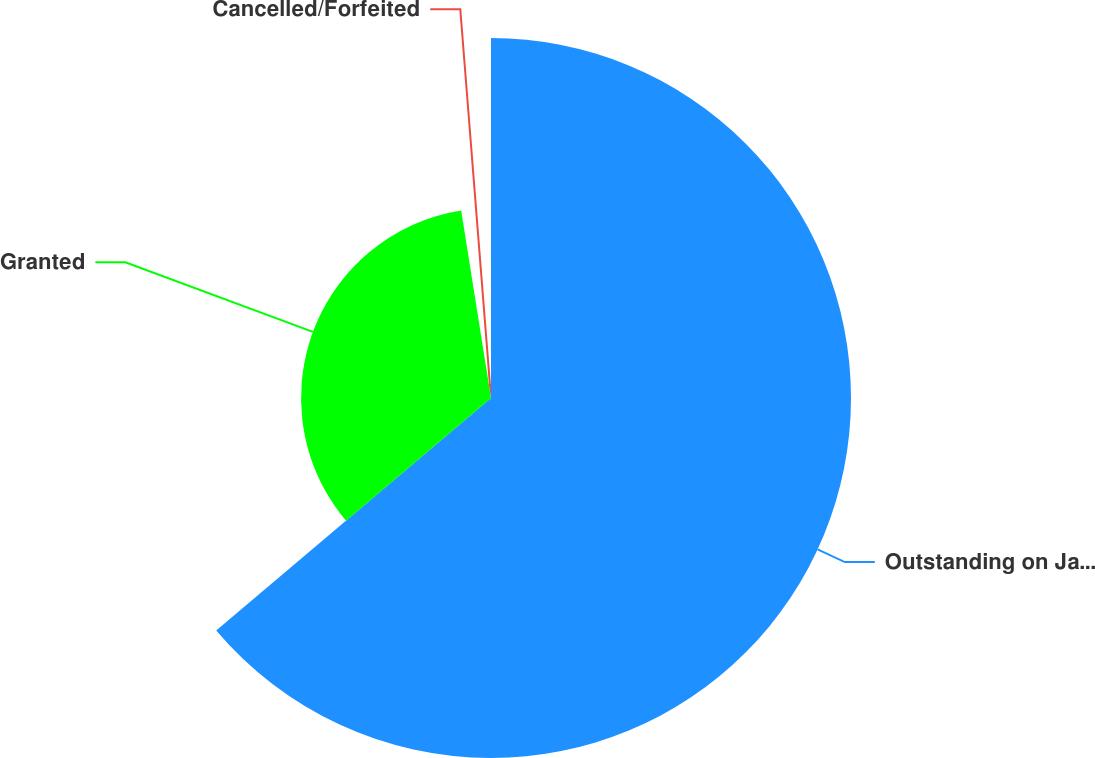Convert chart. <chart><loc_0><loc_0><loc_500><loc_500><pie_chart><fcel>Outstanding on January 1<fcel>Granted<fcel>Cancelled/Forfeited<nl><fcel>63.82%<fcel>33.67%<fcel>2.51%<nl></chart> 